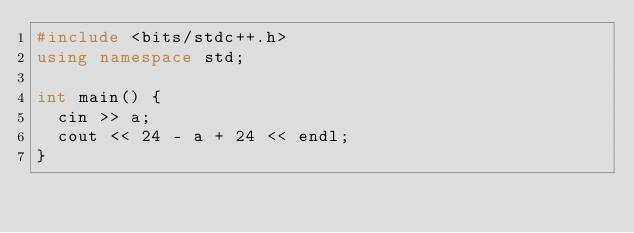Convert code to text. <code><loc_0><loc_0><loc_500><loc_500><_C++_>#include <bits/stdc++.h>
using namespace std;

int main() {
  cin >> a;
  cout << 24 - a + 24 << endl;
}
</code> 